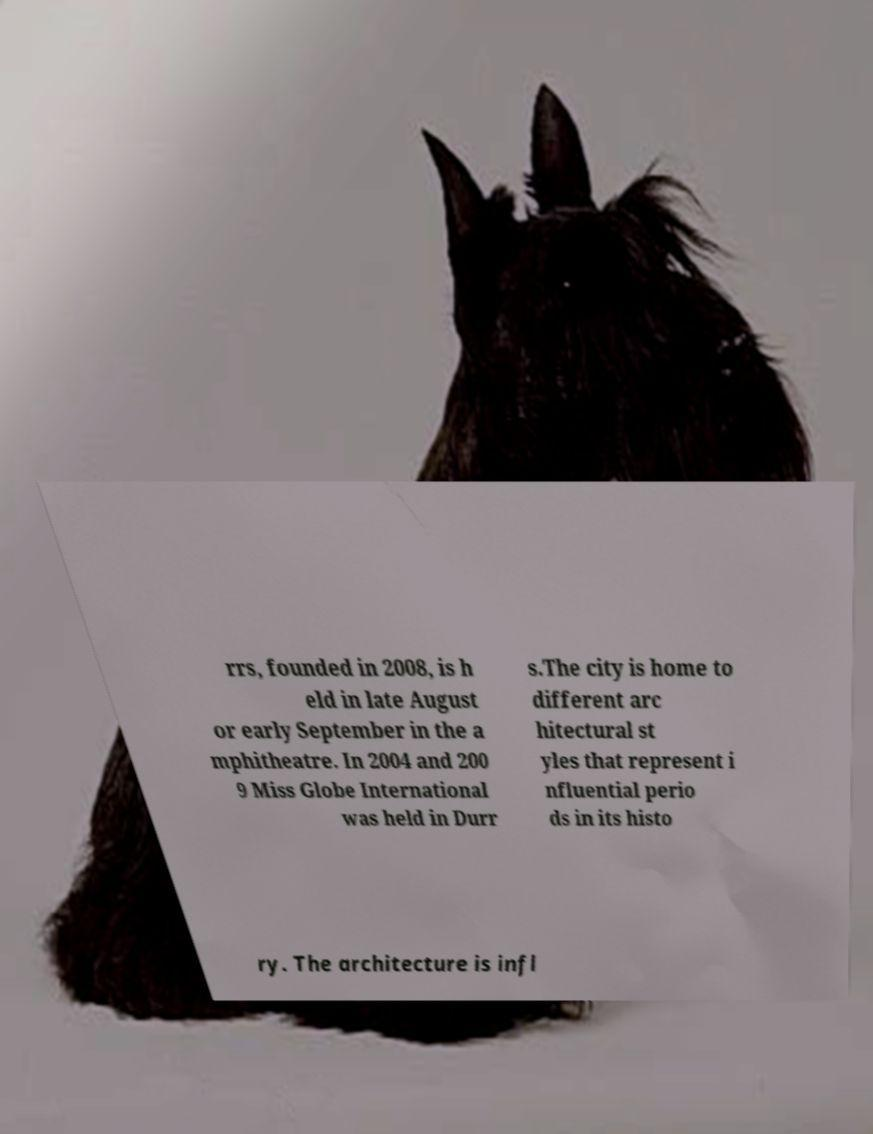I need the written content from this picture converted into text. Can you do that? rrs, founded in 2008, is h eld in late August or early September in the a mphitheatre. In 2004 and 200 9 Miss Globe International was held in Durr s.The city is home to different arc hitectural st yles that represent i nfluential perio ds in its histo ry. The architecture is infl 